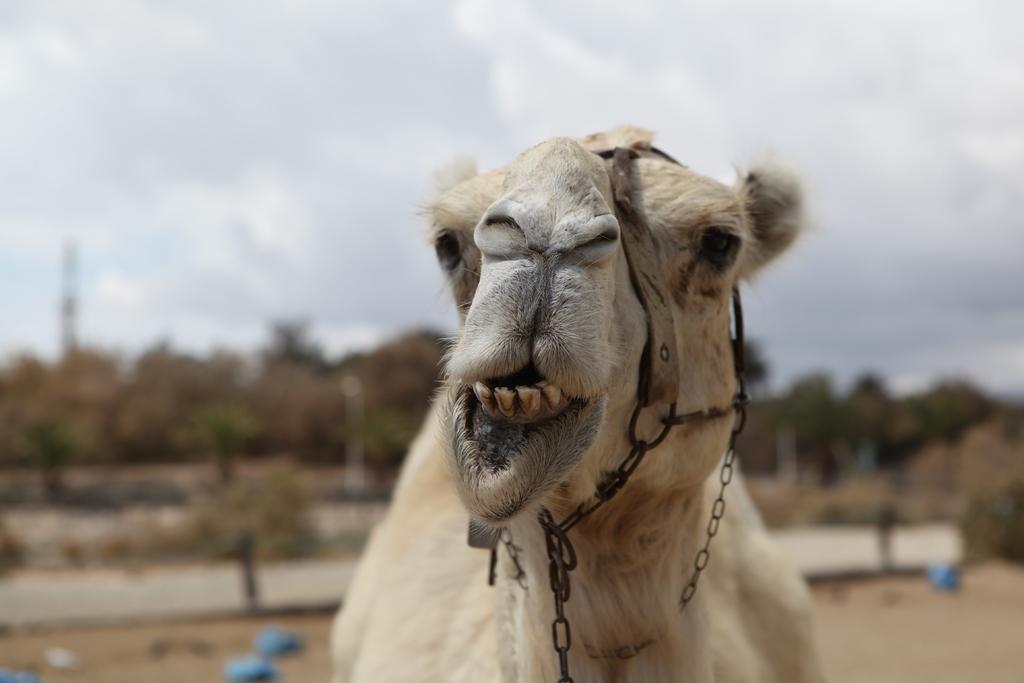In one or two sentences, can you explain what this image depicts? It's a camel which is in brown color. At the top it's a cloudy sky. 